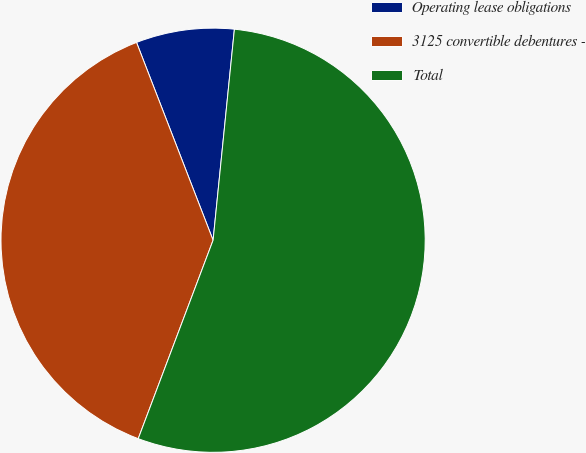Convert chart. <chart><loc_0><loc_0><loc_500><loc_500><pie_chart><fcel>Operating lease obligations<fcel>3125 convertible debentures -<fcel>Total<nl><fcel>7.48%<fcel>38.38%<fcel>54.14%<nl></chart> 